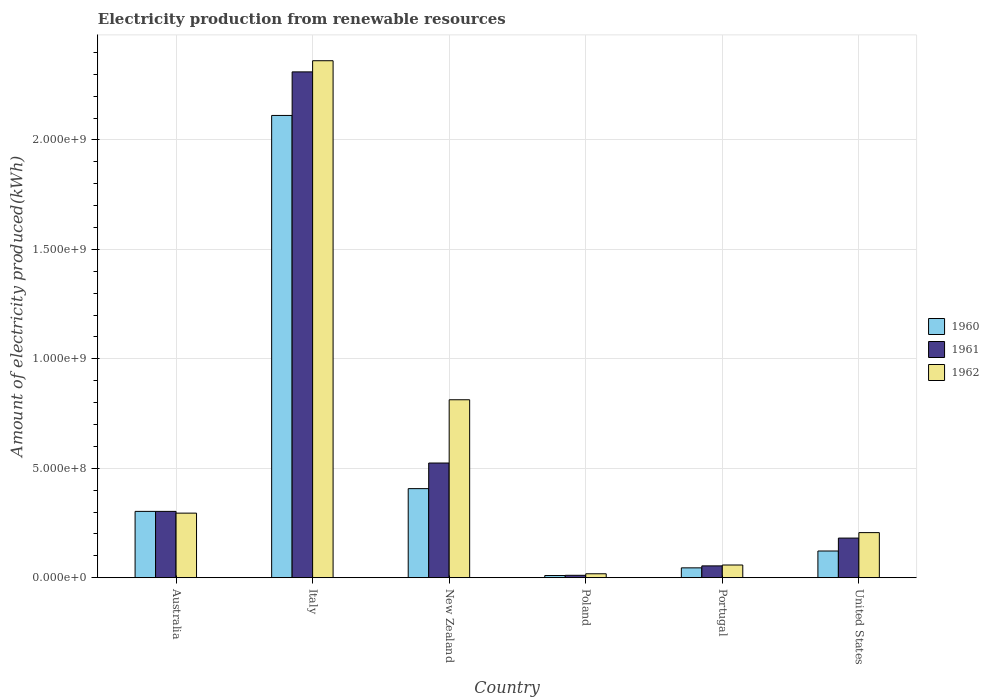How many different coloured bars are there?
Offer a terse response. 3. Are the number of bars per tick equal to the number of legend labels?
Keep it short and to the point. Yes. How many bars are there on the 3rd tick from the right?
Offer a very short reply. 3. What is the label of the 3rd group of bars from the left?
Give a very brief answer. New Zealand. In how many cases, is the number of bars for a given country not equal to the number of legend labels?
Your answer should be compact. 0. What is the amount of electricity produced in 1961 in Poland?
Provide a short and direct response. 1.10e+07. Across all countries, what is the maximum amount of electricity produced in 1962?
Make the answer very short. 2.36e+09. Across all countries, what is the minimum amount of electricity produced in 1962?
Ensure brevity in your answer.  1.80e+07. In which country was the amount of electricity produced in 1962 minimum?
Make the answer very short. Poland. What is the total amount of electricity produced in 1962 in the graph?
Keep it short and to the point. 3.75e+09. What is the difference between the amount of electricity produced in 1960 in Portugal and that in United States?
Your response must be concise. -7.70e+07. What is the difference between the amount of electricity produced in 1961 in Australia and the amount of electricity produced in 1960 in New Zealand?
Your answer should be very brief. -1.04e+08. What is the average amount of electricity produced in 1960 per country?
Your answer should be compact. 5.00e+08. What is the difference between the amount of electricity produced of/in 1961 and amount of electricity produced of/in 1962 in Portugal?
Make the answer very short. -4.00e+06. In how many countries, is the amount of electricity produced in 1962 greater than 800000000 kWh?
Keep it short and to the point. 2. What is the ratio of the amount of electricity produced in 1962 in Italy to that in New Zealand?
Make the answer very short. 2.91. Is the amount of electricity produced in 1960 in Italy less than that in Poland?
Your response must be concise. No. Is the difference between the amount of electricity produced in 1961 in Italy and New Zealand greater than the difference between the amount of electricity produced in 1962 in Italy and New Zealand?
Offer a terse response. Yes. What is the difference between the highest and the second highest amount of electricity produced in 1962?
Your answer should be compact. 1.55e+09. What is the difference between the highest and the lowest amount of electricity produced in 1960?
Offer a terse response. 2.10e+09. What does the 2nd bar from the right in Portugal represents?
Keep it short and to the point. 1961. Is it the case that in every country, the sum of the amount of electricity produced in 1962 and amount of electricity produced in 1961 is greater than the amount of electricity produced in 1960?
Give a very brief answer. Yes. How many bars are there?
Ensure brevity in your answer.  18. How many countries are there in the graph?
Give a very brief answer. 6. What is the difference between two consecutive major ticks on the Y-axis?
Keep it short and to the point. 5.00e+08. Where does the legend appear in the graph?
Provide a succinct answer. Center right. What is the title of the graph?
Give a very brief answer. Electricity production from renewable resources. What is the label or title of the Y-axis?
Provide a succinct answer. Amount of electricity produced(kWh). What is the Amount of electricity produced(kWh) of 1960 in Australia?
Keep it short and to the point. 3.03e+08. What is the Amount of electricity produced(kWh) in 1961 in Australia?
Your response must be concise. 3.03e+08. What is the Amount of electricity produced(kWh) of 1962 in Australia?
Provide a succinct answer. 2.95e+08. What is the Amount of electricity produced(kWh) of 1960 in Italy?
Provide a succinct answer. 2.11e+09. What is the Amount of electricity produced(kWh) in 1961 in Italy?
Your answer should be very brief. 2.31e+09. What is the Amount of electricity produced(kWh) in 1962 in Italy?
Provide a short and direct response. 2.36e+09. What is the Amount of electricity produced(kWh) in 1960 in New Zealand?
Offer a terse response. 4.07e+08. What is the Amount of electricity produced(kWh) of 1961 in New Zealand?
Give a very brief answer. 5.24e+08. What is the Amount of electricity produced(kWh) in 1962 in New Zealand?
Your answer should be compact. 8.13e+08. What is the Amount of electricity produced(kWh) of 1961 in Poland?
Provide a succinct answer. 1.10e+07. What is the Amount of electricity produced(kWh) in 1962 in Poland?
Give a very brief answer. 1.80e+07. What is the Amount of electricity produced(kWh) in 1960 in Portugal?
Provide a short and direct response. 4.50e+07. What is the Amount of electricity produced(kWh) in 1961 in Portugal?
Give a very brief answer. 5.40e+07. What is the Amount of electricity produced(kWh) in 1962 in Portugal?
Give a very brief answer. 5.80e+07. What is the Amount of electricity produced(kWh) of 1960 in United States?
Offer a terse response. 1.22e+08. What is the Amount of electricity produced(kWh) in 1961 in United States?
Make the answer very short. 1.81e+08. What is the Amount of electricity produced(kWh) in 1962 in United States?
Provide a succinct answer. 2.06e+08. Across all countries, what is the maximum Amount of electricity produced(kWh) in 1960?
Make the answer very short. 2.11e+09. Across all countries, what is the maximum Amount of electricity produced(kWh) of 1961?
Make the answer very short. 2.31e+09. Across all countries, what is the maximum Amount of electricity produced(kWh) of 1962?
Provide a succinct answer. 2.36e+09. Across all countries, what is the minimum Amount of electricity produced(kWh) in 1960?
Make the answer very short. 1.00e+07. Across all countries, what is the minimum Amount of electricity produced(kWh) in 1961?
Your response must be concise. 1.10e+07. Across all countries, what is the minimum Amount of electricity produced(kWh) of 1962?
Your response must be concise. 1.80e+07. What is the total Amount of electricity produced(kWh) of 1960 in the graph?
Your response must be concise. 3.00e+09. What is the total Amount of electricity produced(kWh) in 1961 in the graph?
Provide a short and direct response. 3.38e+09. What is the total Amount of electricity produced(kWh) of 1962 in the graph?
Your answer should be very brief. 3.75e+09. What is the difference between the Amount of electricity produced(kWh) in 1960 in Australia and that in Italy?
Provide a succinct answer. -1.81e+09. What is the difference between the Amount of electricity produced(kWh) in 1961 in Australia and that in Italy?
Provide a succinct answer. -2.01e+09. What is the difference between the Amount of electricity produced(kWh) of 1962 in Australia and that in Italy?
Provide a succinct answer. -2.07e+09. What is the difference between the Amount of electricity produced(kWh) of 1960 in Australia and that in New Zealand?
Provide a succinct answer. -1.04e+08. What is the difference between the Amount of electricity produced(kWh) of 1961 in Australia and that in New Zealand?
Provide a short and direct response. -2.21e+08. What is the difference between the Amount of electricity produced(kWh) in 1962 in Australia and that in New Zealand?
Give a very brief answer. -5.18e+08. What is the difference between the Amount of electricity produced(kWh) of 1960 in Australia and that in Poland?
Your response must be concise. 2.93e+08. What is the difference between the Amount of electricity produced(kWh) in 1961 in Australia and that in Poland?
Offer a very short reply. 2.92e+08. What is the difference between the Amount of electricity produced(kWh) in 1962 in Australia and that in Poland?
Ensure brevity in your answer.  2.77e+08. What is the difference between the Amount of electricity produced(kWh) in 1960 in Australia and that in Portugal?
Offer a very short reply. 2.58e+08. What is the difference between the Amount of electricity produced(kWh) in 1961 in Australia and that in Portugal?
Provide a short and direct response. 2.49e+08. What is the difference between the Amount of electricity produced(kWh) in 1962 in Australia and that in Portugal?
Make the answer very short. 2.37e+08. What is the difference between the Amount of electricity produced(kWh) of 1960 in Australia and that in United States?
Give a very brief answer. 1.81e+08. What is the difference between the Amount of electricity produced(kWh) in 1961 in Australia and that in United States?
Provide a short and direct response. 1.22e+08. What is the difference between the Amount of electricity produced(kWh) of 1962 in Australia and that in United States?
Your answer should be very brief. 8.90e+07. What is the difference between the Amount of electricity produced(kWh) of 1960 in Italy and that in New Zealand?
Give a very brief answer. 1.70e+09. What is the difference between the Amount of electricity produced(kWh) of 1961 in Italy and that in New Zealand?
Keep it short and to the point. 1.79e+09. What is the difference between the Amount of electricity produced(kWh) in 1962 in Italy and that in New Zealand?
Offer a very short reply. 1.55e+09. What is the difference between the Amount of electricity produced(kWh) in 1960 in Italy and that in Poland?
Give a very brief answer. 2.10e+09. What is the difference between the Amount of electricity produced(kWh) of 1961 in Italy and that in Poland?
Your response must be concise. 2.30e+09. What is the difference between the Amount of electricity produced(kWh) in 1962 in Italy and that in Poland?
Provide a succinct answer. 2.34e+09. What is the difference between the Amount of electricity produced(kWh) of 1960 in Italy and that in Portugal?
Provide a succinct answer. 2.07e+09. What is the difference between the Amount of electricity produced(kWh) of 1961 in Italy and that in Portugal?
Your response must be concise. 2.26e+09. What is the difference between the Amount of electricity produced(kWh) in 1962 in Italy and that in Portugal?
Give a very brief answer. 2.30e+09. What is the difference between the Amount of electricity produced(kWh) in 1960 in Italy and that in United States?
Provide a short and direct response. 1.99e+09. What is the difference between the Amount of electricity produced(kWh) of 1961 in Italy and that in United States?
Your response must be concise. 2.13e+09. What is the difference between the Amount of electricity produced(kWh) in 1962 in Italy and that in United States?
Ensure brevity in your answer.  2.16e+09. What is the difference between the Amount of electricity produced(kWh) of 1960 in New Zealand and that in Poland?
Your answer should be very brief. 3.97e+08. What is the difference between the Amount of electricity produced(kWh) in 1961 in New Zealand and that in Poland?
Offer a very short reply. 5.13e+08. What is the difference between the Amount of electricity produced(kWh) in 1962 in New Zealand and that in Poland?
Provide a succinct answer. 7.95e+08. What is the difference between the Amount of electricity produced(kWh) of 1960 in New Zealand and that in Portugal?
Make the answer very short. 3.62e+08. What is the difference between the Amount of electricity produced(kWh) in 1961 in New Zealand and that in Portugal?
Provide a succinct answer. 4.70e+08. What is the difference between the Amount of electricity produced(kWh) in 1962 in New Zealand and that in Portugal?
Provide a succinct answer. 7.55e+08. What is the difference between the Amount of electricity produced(kWh) in 1960 in New Zealand and that in United States?
Keep it short and to the point. 2.85e+08. What is the difference between the Amount of electricity produced(kWh) of 1961 in New Zealand and that in United States?
Give a very brief answer. 3.43e+08. What is the difference between the Amount of electricity produced(kWh) of 1962 in New Zealand and that in United States?
Your answer should be compact. 6.07e+08. What is the difference between the Amount of electricity produced(kWh) in 1960 in Poland and that in Portugal?
Offer a terse response. -3.50e+07. What is the difference between the Amount of electricity produced(kWh) of 1961 in Poland and that in Portugal?
Offer a very short reply. -4.30e+07. What is the difference between the Amount of electricity produced(kWh) of 1962 in Poland and that in Portugal?
Provide a short and direct response. -4.00e+07. What is the difference between the Amount of electricity produced(kWh) in 1960 in Poland and that in United States?
Provide a succinct answer. -1.12e+08. What is the difference between the Amount of electricity produced(kWh) in 1961 in Poland and that in United States?
Your response must be concise. -1.70e+08. What is the difference between the Amount of electricity produced(kWh) in 1962 in Poland and that in United States?
Offer a terse response. -1.88e+08. What is the difference between the Amount of electricity produced(kWh) of 1960 in Portugal and that in United States?
Your answer should be compact. -7.70e+07. What is the difference between the Amount of electricity produced(kWh) of 1961 in Portugal and that in United States?
Ensure brevity in your answer.  -1.27e+08. What is the difference between the Amount of electricity produced(kWh) in 1962 in Portugal and that in United States?
Your answer should be compact. -1.48e+08. What is the difference between the Amount of electricity produced(kWh) of 1960 in Australia and the Amount of electricity produced(kWh) of 1961 in Italy?
Make the answer very short. -2.01e+09. What is the difference between the Amount of electricity produced(kWh) of 1960 in Australia and the Amount of electricity produced(kWh) of 1962 in Italy?
Ensure brevity in your answer.  -2.06e+09. What is the difference between the Amount of electricity produced(kWh) in 1961 in Australia and the Amount of electricity produced(kWh) in 1962 in Italy?
Ensure brevity in your answer.  -2.06e+09. What is the difference between the Amount of electricity produced(kWh) of 1960 in Australia and the Amount of electricity produced(kWh) of 1961 in New Zealand?
Give a very brief answer. -2.21e+08. What is the difference between the Amount of electricity produced(kWh) in 1960 in Australia and the Amount of electricity produced(kWh) in 1962 in New Zealand?
Offer a terse response. -5.10e+08. What is the difference between the Amount of electricity produced(kWh) of 1961 in Australia and the Amount of electricity produced(kWh) of 1962 in New Zealand?
Your response must be concise. -5.10e+08. What is the difference between the Amount of electricity produced(kWh) in 1960 in Australia and the Amount of electricity produced(kWh) in 1961 in Poland?
Provide a succinct answer. 2.92e+08. What is the difference between the Amount of electricity produced(kWh) in 1960 in Australia and the Amount of electricity produced(kWh) in 1962 in Poland?
Offer a very short reply. 2.85e+08. What is the difference between the Amount of electricity produced(kWh) in 1961 in Australia and the Amount of electricity produced(kWh) in 1962 in Poland?
Your answer should be compact. 2.85e+08. What is the difference between the Amount of electricity produced(kWh) in 1960 in Australia and the Amount of electricity produced(kWh) in 1961 in Portugal?
Give a very brief answer. 2.49e+08. What is the difference between the Amount of electricity produced(kWh) of 1960 in Australia and the Amount of electricity produced(kWh) of 1962 in Portugal?
Offer a terse response. 2.45e+08. What is the difference between the Amount of electricity produced(kWh) of 1961 in Australia and the Amount of electricity produced(kWh) of 1962 in Portugal?
Your response must be concise. 2.45e+08. What is the difference between the Amount of electricity produced(kWh) in 1960 in Australia and the Amount of electricity produced(kWh) in 1961 in United States?
Keep it short and to the point. 1.22e+08. What is the difference between the Amount of electricity produced(kWh) of 1960 in Australia and the Amount of electricity produced(kWh) of 1962 in United States?
Offer a terse response. 9.70e+07. What is the difference between the Amount of electricity produced(kWh) in 1961 in Australia and the Amount of electricity produced(kWh) in 1962 in United States?
Ensure brevity in your answer.  9.70e+07. What is the difference between the Amount of electricity produced(kWh) in 1960 in Italy and the Amount of electricity produced(kWh) in 1961 in New Zealand?
Offer a terse response. 1.59e+09. What is the difference between the Amount of electricity produced(kWh) of 1960 in Italy and the Amount of electricity produced(kWh) of 1962 in New Zealand?
Your answer should be compact. 1.30e+09. What is the difference between the Amount of electricity produced(kWh) in 1961 in Italy and the Amount of electricity produced(kWh) in 1962 in New Zealand?
Ensure brevity in your answer.  1.50e+09. What is the difference between the Amount of electricity produced(kWh) in 1960 in Italy and the Amount of electricity produced(kWh) in 1961 in Poland?
Keep it short and to the point. 2.10e+09. What is the difference between the Amount of electricity produced(kWh) of 1960 in Italy and the Amount of electricity produced(kWh) of 1962 in Poland?
Provide a short and direct response. 2.09e+09. What is the difference between the Amount of electricity produced(kWh) in 1961 in Italy and the Amount of electricity produced(kWh) in 1962 in Poland?
Offer a very short reply. 2.29e+09. What is the difference between the Amount of electricity produced(kWh) of 1960 in Italy and the Amount of electricity produced(kWh) of 1961 in Portugal?
Provide a short and direct response. 2.06e+09. What is the difference between the Amount of electricity produced(kWh) in 1960 in Italy and the Amount of electricity produced(kWh) in 1962 in Portugal?
Offer a terse response. 2.05e+09. What is the difference between the Amount of electricity produced(kWh) of 1961 in Italy and the Amount of electricity produced(kWh) of 1962 in Portugal?
Give a very brief answer. 2.25e+09. What is the difference between the Amount of electricity produced(kWh) of 1960 in Italy and the Amount of electricity produced(kWh) of 1961 in United States?
Ensure brevity in your answer.  1.93e+09. What is the difference between the Amount of electricity produced(kWh) of 1960 in Italy and the Amount of electricity produced(kWh) of 1962 in United States?
Your answer should be compact. 1.91e+09. What is the difference between the Amount of electricity produced(kWh) in 1961 in Italy and the Amount of electricity produced(kWh) in 1962 in United States?
Keep it short and to the point. 2.10e+09. What is the difference between the Amount of electricity produced(kWh) in 1960 in New Zealand and the Amount of electricity produced(kWh) in 1961 in Poland?
Your answer should be compact. 3.96e+08. What is the difference between the Amount of electricity produced(kWh) of 1960 in New Zealand and the Amount of electricity produced(kWh) of 1962 in Poland?
Your answer should be very brief. 3.89e+08. What is the difference between the Amount of electricity produced(kWh) of 1961 in New Zealand and the Amount of electricity produced(kWh) of 1962 in Poland?
Your response must be concise. 5.06e+08. What is the difference between the Amount of electricity produced(kWh) of 1960 in New Zealand and the Amount of electricity produced(kWh) of 1961 in Portugal?
Your answer should be compact. 3.53e+08. What is the difference between the Amount of electricity produced(kWh) of 1960 in New Zealand and the Amount of electricity produced(kWh) of 1962 in Portugal?
Offer a terse response. 3.49e+08. What is the difference between the Amount of electricity produced(kWh) of 1961 in New Zealand and the Amount of electricity produced(kWh) of 1962 in Portugal?
Offer a terse response. 4.66e+08. What is the difference between the Amount of electricity produced(kWh) of 1960 in New Zealand and the Amount of electricity produced(kWh) of 1961 in United States?
Your answer should be compact. 2.26e+08. What is the difference between the Amount of electricity produced(kWh) of 1960 in New Zealand and the Amount of electricity produced(kWh) of 1962 in United States?
Ensure brevity in your answer.  2.01e+08. What is the difference between the Amount of electricity produced(kWh) in 1961 in New Zealand and the Amount of electricity produced(kWh) in 1962 in United States?
Offer a very short reply. 3.18e+08. What is the difference between the Amount of electricity produced(kWh) of 1960 in Poland and the Amount of electricity produced(kWh) of 1961 in Portugal?
Ensure brevity in your answer.  -4.40e+07. What is the difference between the Amount of electricity produced(kWh) of 1960 in Poland and the Amount of electricity produced(kWh) of 1962 in Portugal?
Your answer should be very brief. -4.80e+07. What is the difference between the Amount of electricity produced(kWh) of 1961 in Poland and the Amount of electricity produced(kWh) of 1962 in Portugal?
Your answer should be very brief. -4.70e+07. What is the difference between the Amount of electricity produced(kWh) of 1960 in Poland and the Amount of electricity produced(kWh) of 1961 in United States?
Give a very brief answer. -1.71e+08. What is the difference between the Amount of electricity produced(kWh) in 1960 in Poland and the Amount of electricity produced(kWh) in 1962 in United States?
Offer a very short reply. -1.96e+08. What is the difference between the Amount of electricity produced(kWh) of 1961 in Poland and the Amount of electricity produced(kWh) of 1962 in United States?
Your answer should be very brief. -1.95e+08. What is the difference between the Amount of electricity produced(kWh) in 1960 in Portugal and the Amount of electricity produced(kWh) in 1961 in United States?
Provide a succinct answer. -1.36e+08. What is the difference between the Amount of electricity produced(kWh) in 1960 in Portugal and the Amount of electricity produced(kWh) in 1962 in United States?
Keep it short and to the point. -1.61e+08. What is the difference between the Amount of electricity produced(kWh) of 1961 in Portugal and the Amount of electricity produced(kWh) of 1962 in United States?
Provide a short and direct response. -1.52e+08. What is the average Amount of electricity produced(kWh) of 1960 per country?
Your answer should be compact. 5.00e+08. What is the average Amount of electricity produced(kWh) of 1961 per country?
Your answer should be very brief. 5.64e+08. What is the average Amount of electricity produced(kWh) in 1962 per country?
Offer a terse response. 6.25e+08. What is the difference between the Amount of electricity produced(kWh) of 1960 and Amount of electricity produced(kWh) of 1961 in Australia?
Give a very brief answer. 0. What is the difference between the Amount of electricity produced(kWh) of 1960 and Amount of electricity produced(kWh) of 1962 in Australia?
Your answer should be very brief. 8.00e+06. What is the difference between the Amount of electricity produced(kWh) of 1960 and Amount of electricity produced(kWh) of 1961 in Italy?
Your answer should be very brief. -1.99e+08. What is the difference between the Amount of electricity produced(kWh) of 1960 and Amount of electricity produced(kWh) of 1962 in Italy?
Make the answer very short. -2.50e+08. What is the difference between the Amount of electricity produced(kWh) of 1961 and Amount of electricity produced(kWh) of 1962 in Italy?
Your answer should be very brief. -5.10e+07. What is the difference between the Amount of electricity produced(kWh) of 1960 and Amount of electricity produced(kWh) of 1961 in New Zealand?
Provide a short and direct response. -1.17e+08. What is the difference between the Amount of electricity produced(kWh) in 1960 and Amount of electricity produced(kWh) in 1962 in New Zealand?
Offer a terse response. -4.06e+08. What is the difference between the Amount of electricity produced(kWh) in 1961 and Amount of electricity produced(kWh) in 1962 in New Zealand?
Keep it short and to the point. -2.89e+08. What is the difference between the Amount of electricity produced(kWh) of 1960 and Amount of electricity produced(kWh) of 1961 in Poland?
Offer a terse response. -1.00e+06. What is the difference between the Amount of electricity produced(kWh) in 1960 and Amount of electricity produced(kWh) in 1962 in Poland?
Your response must be concise. -8.00e+06. What is the difference between the Amount of electricity produced(kWh) in 1961 and Amount of electricity produced(kWh) in 1962 in Poland?
Your response must be concise. -7.00e+06. What is the difference between the Amount of electricity produced(kWh) in 1960 and Amount of electricity produced(kWh) in 1961 in Portugal?
Ensure brevity in your answer.  -9.00e+06. What is the difference between the Amount of electricity produced(kWh) of 1960 and Amount of electricity produced(kWh) of 1962 in Portugal?
Your answer should be compact. -1.30e+07. What is the difference between the Amount of electricity produced(kWh) in 1961 and Amount of electricity produced(kWh) in 1962 in Portugal?
Make the answer very short. -4.00e+06. What is the difference between the Amount of electricity produced(kWh) of 1960 and Amount of electricity produced(kWh) of 1961 in United States?
Keep it short and to the point. -5.90e+07. What is the difference between the Amount of electricity produced(kWh) of 1960 and Amount of electricity produced(kWh) of 1962 in United States?
Give a very brief answer. -8.40e+07. What is the difference between the Amount of electricity produced(kWh) in 1961 and Amount of electricity produced(kWh) in 1962 in United States?
Provide a short and direct response. -2.50e+07. What is the ratio of the Amount of electricity produced(kWh) of 1960 in Australia to that in Italy?
Provide a succinct answer. 0.14. What is the ratio of the Amount of electricity produced(kWh) of 1961 in Australia to that in Italy?
Provide a succinct answer. 0.13. What is the ratio of the Amount of electricity produced(kWh) in 1962 in Australia to that in Italy?
Ensure brevity in your answer.  0.12. What is the ratio of the Amount of electricity produced(kWh) of 1960 in Australia to that in New Zealand?
Provide a short and direct response. 0.74. What is the ratio of the Amount of electricity produced(kWh) in 1961 in Australia to that in New Zealand?
Ensure brevity in your answer.  0.58. What is the ratio of the Amount of electricity produced(kWh) in 1962 in Australia to that in New Zealand?
Make the answer very short. 0.36. What is the ratio of the Amount of electricity produced(kWh) in 1960 in Australia to that in Poland?
Give a very brief answer. 30.3. What is the ratio of the Amount of electricity produced(kWh) in 1961 in Australia to that in Poland?
Provide a short and direct response. 27.55. What is the ratio of the Amount of electricity produced(kWh) in 1962 in Australia to that in Poland?
Make the answer very short. 16.39. What is the ratio of the Amount of electricity produced(kWh) in 1960 in Australia to that in Portugal?
Your answer should be very brief. 6.73. What is the ratio of the Amount of electricity produced(kWh) of 1961 in Australia to that in Portugal?
Provide a succinct answer. 5.61. What is the ratio of the Amount of electricity produced(kWh) of 1962 in Australia to that in Portugal?
Provide a short and direct response. 5.09. What is the ratio of the Amount of electricity produced(kWh) of 1960 in Australia to that in United States?
Offer a terse response. 2.48. What is the ratio of the Amount of electricity produced(kWh) of 1961 in Australia to that in United States?
Provide a succinct answer. 1.67. What is the ratio of the Amount of electricity produced(kWh) in 1962 in Australia to that in United States?
Give a very brief answer. 1.43. What is the ratio of the Amount of electricity produced(kWh) of 1960 in Italy to that in New Zealand?
Provide a succinct answer. 5.19. What is the ratio of the Amount of electricity produced(kWh) of 1961 in Italy to that in New Zealand?
Offer a terse response. 4.41. What is the ratio of the Amount of electricity produced(kWh) of 1962 in Italy to that in New Zealand?
Offer a terse response. 2.91. What is the ratio of the Amount of electricity produced(kWh) in 1960 in Italy to that in Poland?
Give a very brief answer. 211.2. What is the ratio of the Amount of electricity produced(kWh) of 1961 in Italy to that in Poland?
Your answer should be compact. 210.09. What is the ratio of the Amount of electricity produced(kWh) in 1962 in Italy to that in Poland?
Offer a terse response. 131.22. What is the ratio of the Amount of electricity produced(kWh) in 1960 in Italy to that in Portugal?
Your answer should be compact. 46.93. What is the ratio of the Amount of electricity produced(kWh) of 1961 in Italy to that in Portugal?
Ensure brevity in your answer.  42.8. What is the ratio of the Amount of electricity produced(kWh) of 1962 in Italy to that in Portugal?
Your answer should be compact. 40.72. What is the ratio of the Amount of electricity produced(kWh) in 1960 in Italy to that in United States?
Provide a short and direct response. 17.31. What is the ratio of the Amount of electricity produced(kWh) in 1961 in Italy to that in United States?
Keep it short and to the point. 12.77. What is the ratio of the Amount of electricity produced(kWh) of 1962 in Italy to that in United States?
Ensure brevity in your answer.  11.47. What is the ratio of the Amount of electricity produced(kWh) of 1960 in New Zealand to that in Poland?
Offer a terse response. 40.7. What is the ratio of the Amount of electricity produced(kWh) of 1961 in New Zealand to that in Poland?
Your answer should be compact. 47.64. What is the ratio of the Amount of electricity produced(kWh) of 1962 in New Zealand to that in Poland?
Your answer should be compact. 45.17. What is the ratio of the Amount of electricity produced(kWh) in 1960 in New Zealand to that in Portugal?
Offer a terse response. 9.04. What is the ratio of the Amount of electricity produced(kWh) in 1961 in New Zealand to that in Portugal?
Offer a very short reply. 9.7. What is the ratio of the Amount of electricity produced(kWh) in 1962 in New Zealand to that in Portugal?
Ensure brevity in your answer.  14.02. What is the ratio of the Amount of electricity produced(kWh) of 1960 in New Zealand to that in United States?
Your answer should be compact. 3.34. What is the ratio of the Amount of electricity produced(kWh) in 1961 in New Zealand to that in United States?
Your response must be concise. 2.9. What is the ratio of the Amount of electricity produced(kWh) of 1962 in New Zealand to that in United States?
Offer a terse response. 3.95. What is the ratio of the Amount of electricity produced(kWh) of 1960 in Poland to that in Portugal?
Make the answer very short. 0.22. What is the ratio of the Amount of electricity produced(kWh) in 1961 in Poland to that in Portugal?
Your answer should be very brief. 0.2. What is the ratio of the Amount of electricity produced(kWh) in 1962 in Poland to that in Portugal?
Your answer should be very brief. 0.31. What is the ratio of the Amount of electricity produced(kWh) of 1960 in Poland to that in United States?
Give a very brief answer. 0.08. What is the ratio of the Amount of electricity produced(kWh) of 1961 in Poland to that in United States?
Make the answer very short. 0.06. What is the ratio of the Amount of electricity produced(kWh) of 1962 in Poland to that in United States?
Keep it short and to the point. 0.09. What is the ratio of the Amount of electricity produced(kWh) in 1960 in Portugal to that in United States?
Make the answer very short. 0.37. What is the ratio of the Amount of electricity produced(kWh) of 1961 in Portugal to that in United States?
Provide a short and direct response. 0.3. What is the ratio of the Amount of electricity produced(kWh) in 1962 in Portugal to that in United States?
Your answer should be compact. 0.28. What is the difference between the highest and the second highest Amount of electricity produced(kWh) in 1960?
Offer a very short reply. 1.70e+09. What is the difference between the highest and the second highest Amount of electricity produced(kWh) in 1961?
Your response must be concise. 1.79e+09. What is the difference between the highest and the second highest Amount of electricity produced(kWh) of 1962?
Make the answer very short. 1.55e+09. What is the difference between the highest and the lowest Amount of electricity produced(kWh) of 1960?
Make the answer very short. 2.10e+09. What is the difference between the highest and the lowest Amount of electricity produced(kWh) of 1961?
Your answer should be compact. 2.30e+09. What is the difference between the highest and the lowest Amount of electricity produced(kWh) in 1962?
Make the answer very short. 2.34e+09. 